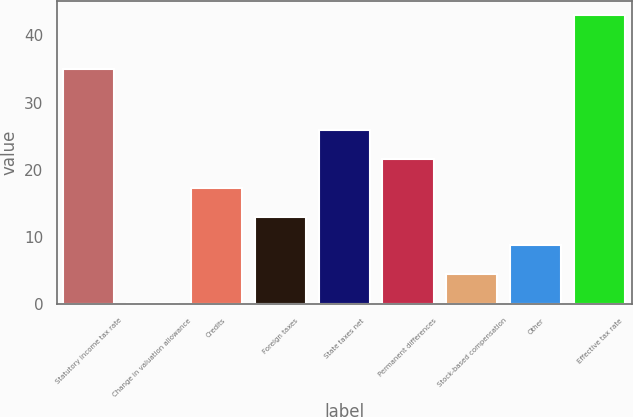Convert chart. <chart><loc_0><loc_0><loc_500><loc_500><bar_chart><fcel>Statutory income tax rate<fcel>Change in valuation allowance<fcel>Credits<fcel>Foreign taxes<fcel>State taxes net<fcel>Permanent differences<fcel>Stock-based compensation<fcel>Other<fcel>Effective tax rate<nl><fcel>35<fcel>0.2<fcel>17.32<fcel>13.04<fcel>25.88<fcel>21.6<fcel>4.48<fcel>8.76<fcel>43<nl></chart> 